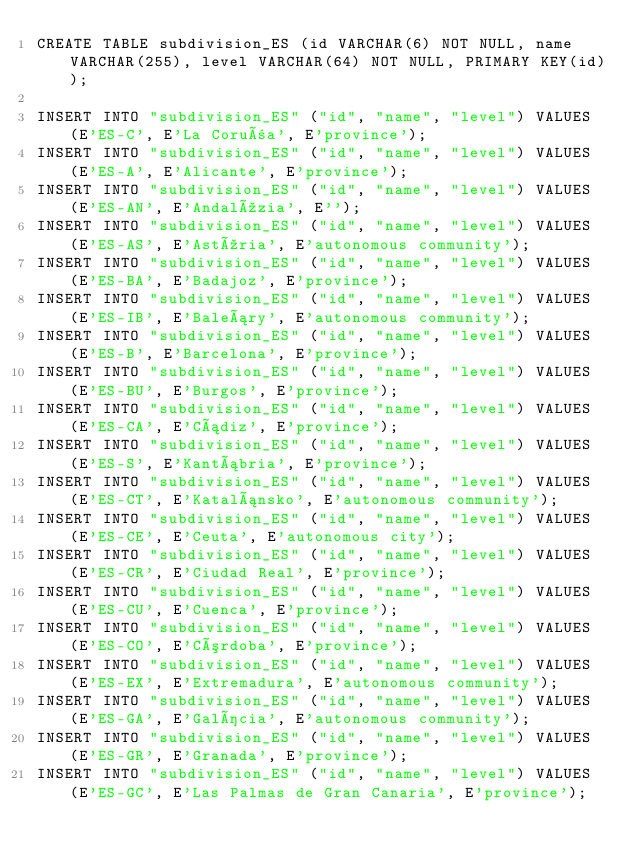<code> <loc_0><loc_0><loc_500><loc_500><_SQL_>CREATE TABLE subdivision_ES (id VARCHAR(6) NOT NULL, name VARCHAR(255), level VARCHAR(64) NOT NULL, PRIMARY KEY(id));

INSERT INTO "subdivision_ES" ("id", "name", "level") VALUES (E'ES-C', E'La Coruña', E'province');
INSERT INTO "subdivision_ES" ("id", "name", "level") VALUES (E'ES-A', E'Alicante', E'province');
INSERT INTO "subdivision_ES" ("id", "name", "level") VALUES (E'ES-AN', E'Andalúzia', E'');
INSERT INTO "subdivision_ES" ("id", "name", "level") VALUES (E'ES-AS', E'Astúria', E'autonomous community');
INSERT INTO "subdivision_ES" ("id", "name", "level") VALUES (E'ES-BA', E'Badajoz', E'province');
INSERT INTO "subdivision_ES" ("id", "name", "level") VALUES (E'ES-IB', E'Baleáry', E'autonomous community');
INSERT INTO "subdivision_ES" ("id", "name", "level") VALUES (E'ES-B', E'Barcelona', E'province');
INSERT INTO "subdivision_ES" ("id", "name", "level") VALUES (E'ES-BU', E'Burgos', E'province');
INSERT INTO "subdivision_ES" ("id", "name", "level") VALUES (E'ES-CA', E'Cádiz', E'province');
INSERT INTO "subdivision_ES" ("id", "name", "level") VALUES (E'ES-S', E'Kantábria', E'province');
INSERT INTO "subdivision_ES" ("id", "name", "level") VALUES (E'ES-CT', E'Katalánsko', E'autonomous community');
INSERT INTO "subdivision_ES" ("id", "name", "level") VALUES (E'ES-CE', E'Ceuta', E'autonomous city');
INSERT INTO "subdivision_ES" ("id", "name", "level") VALUES (E'ES-CR', E'Ciudad Real', E'province');
INSERT INTO "subdivision_ES" ("id", "name", "level") VALUES (E'ES-CU', E'Cuenca', E'province');
INSERT INTO "subdivision_ES" ("id", "name", "level") VALUES (E'ES-CO', E'Córdoba', E'province');
INSERT INTO "subdivision_ES" ("id", "name", "level") VALUES (E'ES-EX', E'Extremadura', E'autonomous community');
INSERT INTO "subdivision_ES" ("id", "name", "level") VALUES (E'ES-GA', E'Galícia', E'autonomous community');
INSERT INTO "subdivision_ES" ("id", "name", "level") VALUES (E'ES-GR', E'Granada', E'province');
INSERT INTO "subdivision_ES" ("id", "name", "level") VALUES (E'ES-GC', E'Las Palmas de Gran Canaria', E'province');</code> 